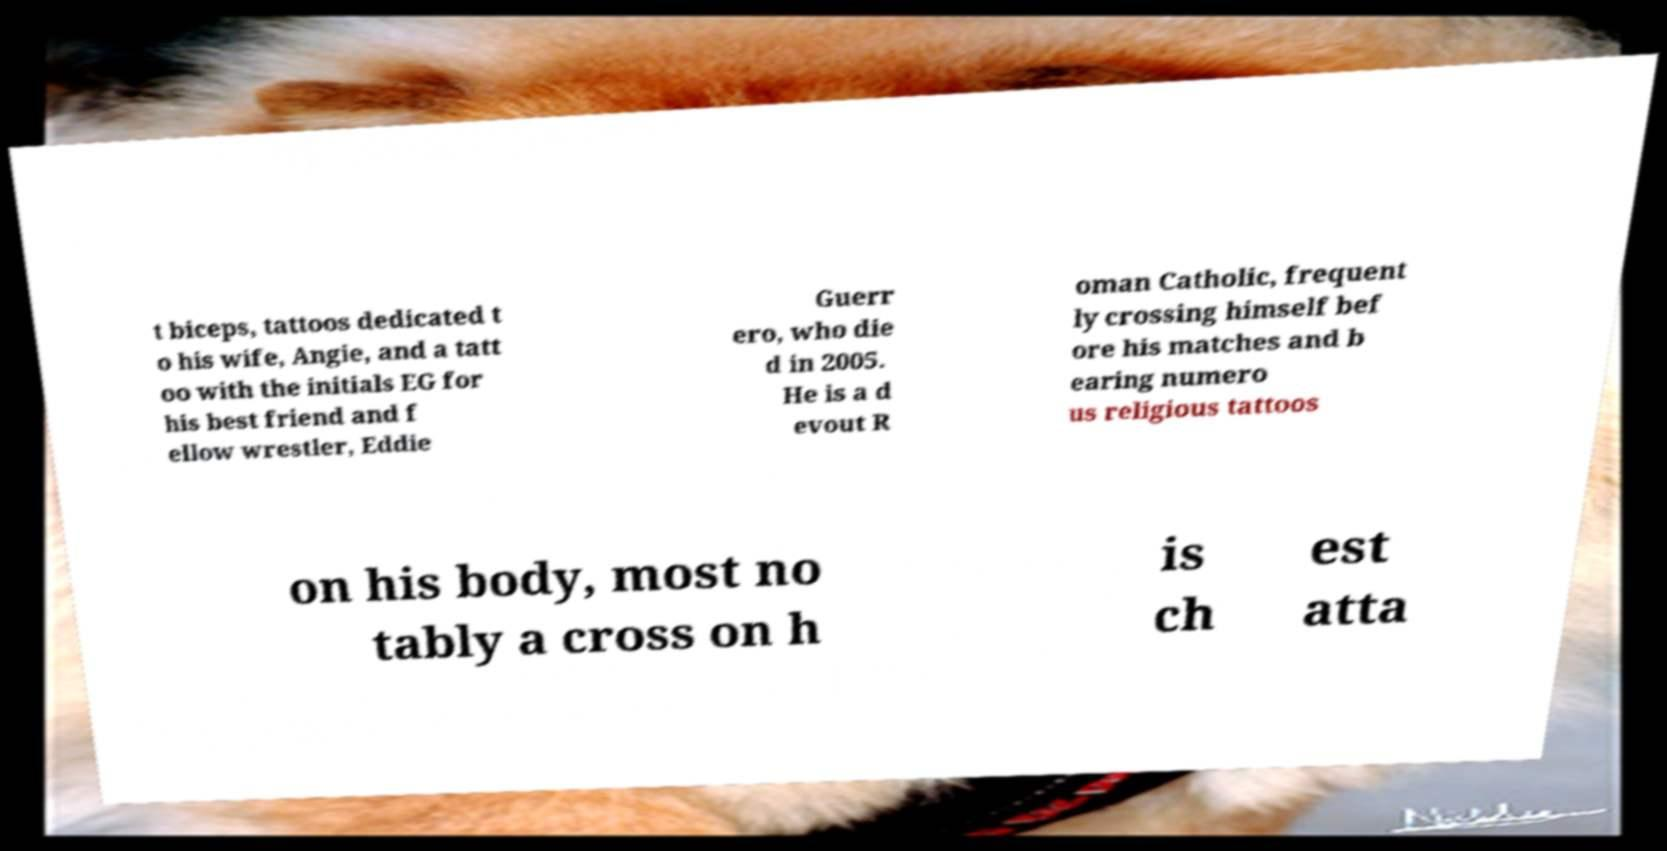There's text embedded in this image that I need extracted. Can you transcribe it verbatim? t biceps, tattoos dedicated t o his wife, Angie, and a tatt oo with the initials EG for his best friend and f ellow wrestler, Eddie Guerr ero, who die d in 2005. He is a d evout R oman Catholic, frequent ly crossing himself bef ore his matches and b earing numero us religious tattoos on his body, most no tably a cross on h is ch est atta 